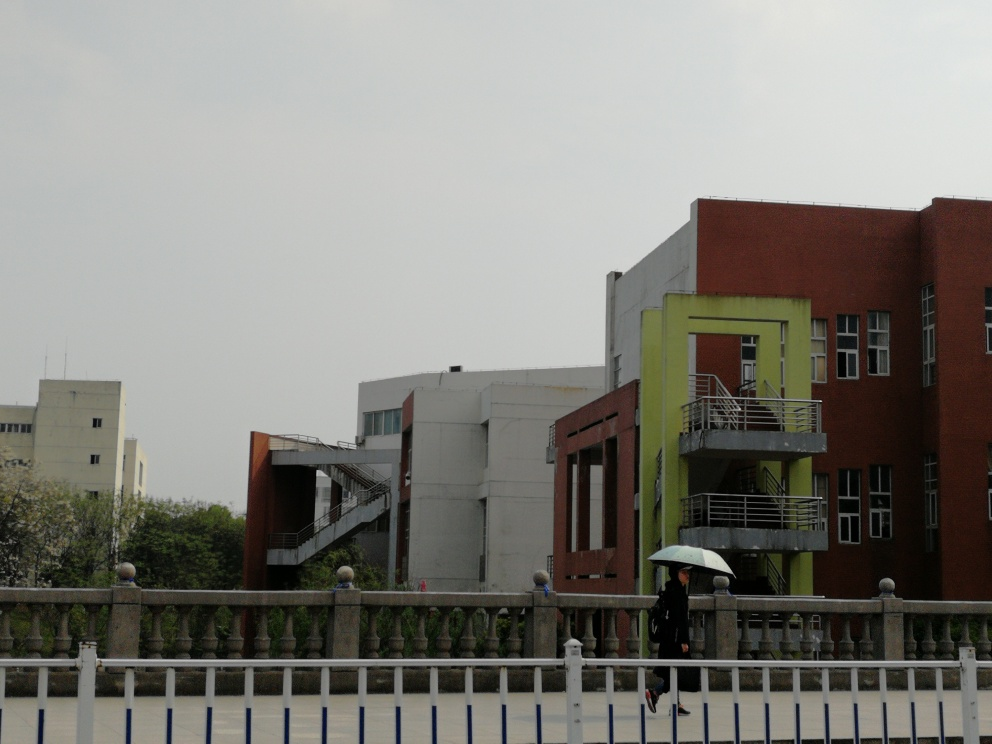What is the overall quality of the image? The overall quality of the image is average; it appears to be slightly overcast, which can make the lighting seem flat, and while the focus is clear, the composition and colors don't seem to be particularly vibrant or eye-catching. Additionally, there are no apparent filters or effects applied that could enhance the artistic quality. 